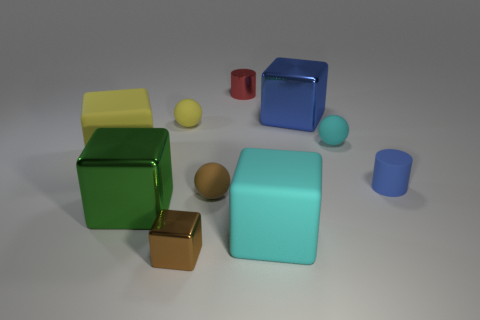Subtract 2 cubes. How many cubes are left? 3 Subtract all gray blocks. Subtract all blue cylinders. How many blocks are left? 5 Subtract all balls. How many objects are left? 7 Add 5 big blue rubber blocks. How many big blue rubber blocks exist? 5 Subtract 1 blue cylinders. How many objects are left? 9 Subtract all small yellow matte balls. Subtract all green shiny things. How many objects are left? 8 Add 6 blue blocks. How many blue blocks are left? 7 